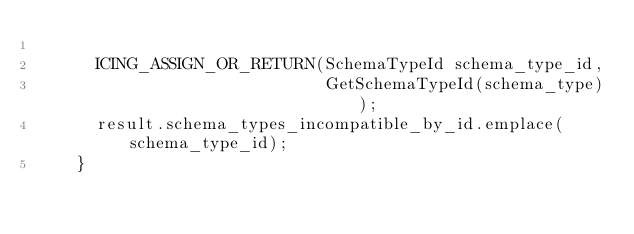<code> <loc_0><loc_0><loc_500><loc_500><_C++_>
      ICING_ASSIGN_OR_RETURN(SchemaTypeId schema_type_id,
                             GetSchemaTypeId(schema_type));
      result.schema_types_incompatible_by_id.emplace(schema_type_id);
    }
</code> 